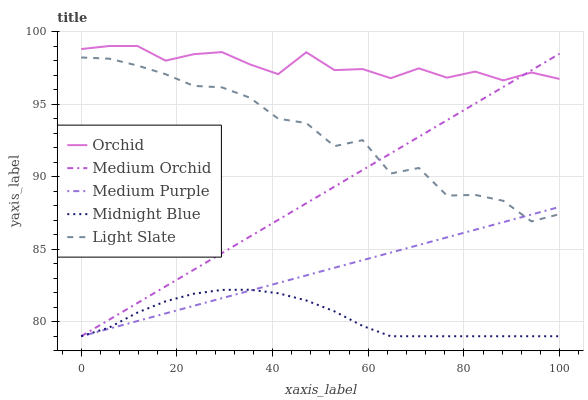Does Midnight Blue have the minimum area under the curve?
Answer yes or no. Yes. Does Orchid have the maximum area under the curve?
Answer yes or no. Yes. Does Light Slate have the minimum area under the curve?
Answer yes or no. No. Does Light Slate have the maximum area under the curve?
Answer yes or no. No. Is Medium Orchid the smoothest?
Answer yes or no. Yes. Is Light Slate the roughest?
Answer yes or no. Yes. Is Light Slate the smoothest?
Answer yes or no. No. Is Medium Orchid the roughest?
Answer yes or no. No. Does Medium Purple have the lowest value?
Answer yes or no. Yes. Does Light Slate have the lowest value?
Answer yes or no. No. Does Orchid have the highest value?
Answer yes or no. Yes. Does Light Slate have the highest value?
Answer yes or no. No. Is Medium Purple less than Orchid?
Answer yes or no. Yes. Is Orchid greater than Light Slate?
Answer yes or no. Yes. Does Midnight Blue intersect Medium Purple?
Answer yes or no. Yes. Is Midnight Blue less than Medium Purple?
Answer yes or no. No. Is Midnight Blue greater than Medium Purple?
Answer yes or no. No. Does Medium Purple intersect Orchid?
Answer yes or no. No. 